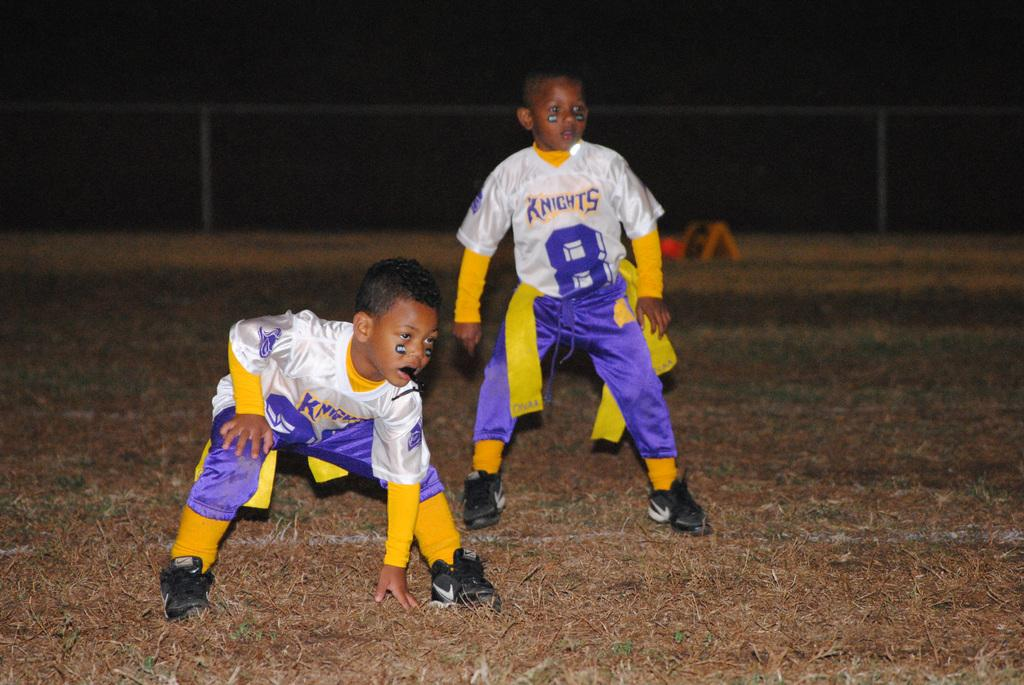<image>
Render a clear and concise summary of the photo. Two children stand ready to play football, one in a #8 Knights jersey. 